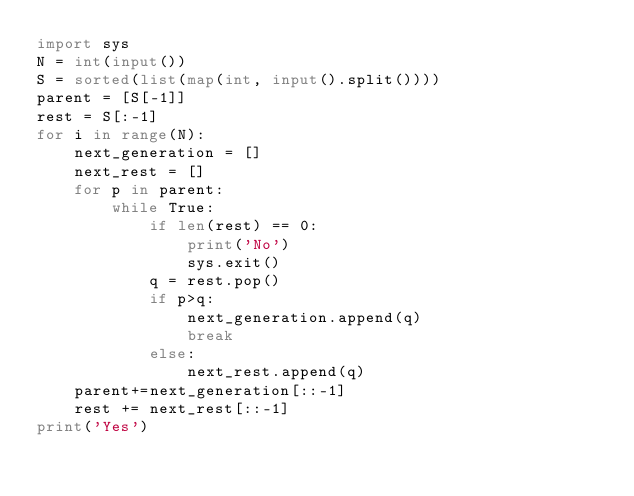<code> <loc_0><loc_0><loc_500><loc_500><_Python_>import sys
N = int(input())
S = sorted(list(map(int, input().split())))
parent = [S[-1]]
rest = S[:-1]
for i in range(N):
    next_generation = []
    next_rest = []
    for p in parent:
        while True:
            if len(rest) == 0:
                print('No')
                sys.exit()
            q = rest.pop()
            if p>q:
                next_generation.append(q)
                break
            else:
                next_rest.append(q)
    parent+=next_generation[::-1]
    rest += next_rest[::-1]
print('Yes')   </code> 